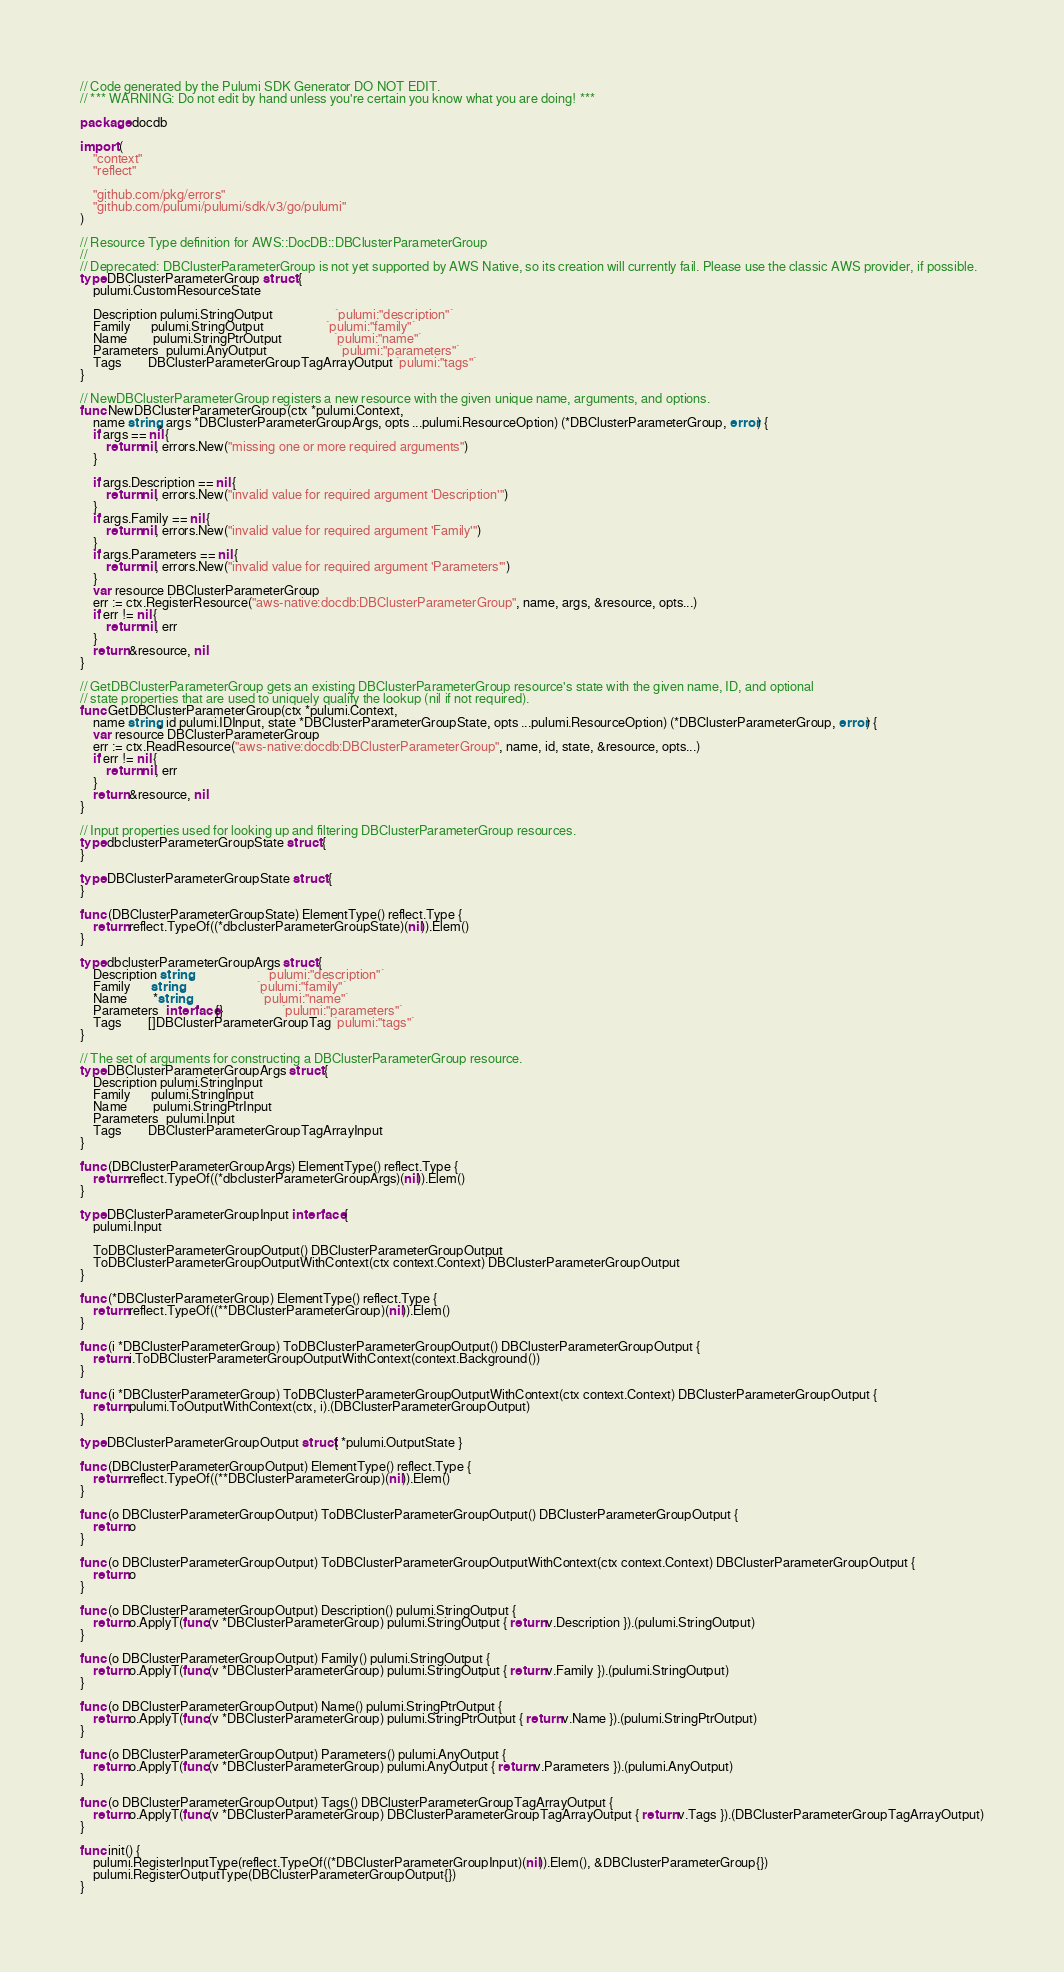<code> <loc_0><loc_0><loc_500><loc_500><_Go_>// Code generated by the Pulumi SDK Generator DO NOT EDIT.
// *** WARNING: Do not edit by hand unless you're certain you know what you are doing! ***

package docdb

import (
	"context"
	"reflect"

	"github.com/pkg/errors"
	"github.com/pulumi/pulumi/sdk/v3/go/pulumi"
)

// Resource Type definition for AWS::DocDB::DBClusterParameterGroup
//
// Deprecated: DBClusterParameterGroup is not yet supported by AWS Native, so its creation will currently fail. Please use the classic AWS provider, if possible.
type DBClusterParameterGroup struct {
	pulumi.CustomResourceState

	Description pulumi.StringOutput                   `pulumi:"description"`
	Family      pulumi.StringOutput                   `pulumi:"family"`
	Name        pulumi.StringPtrOutput                `pulumi:"name"`
	Parameters  pulumi.AnyOutput                      `pulumi:"parameters"`
	Tags        DBClusterParameterGroupTagArrayOutput `pulumi:"tags"`
}

// NewDBClusterParameterGroup registers a new resource with the given unique name, arguments, and options.
func NewDBClusterParameterGroup(ctx *pulumi.Context,
	name string, args *DBClusterParameterGroupArgs, opts ...pulumi.ResourceOption) (*DBClusterParameterGroup, error) {
	if args == nil {
		return nil, errors.New("missing one or more required arguments")
	}

	if args.Description == nil {
		return nil, errors.New("invalid value for required argument 'Description'")
	}
	if args.Family == nil {
		return nil, errors.New("invalid value for required argument 'Family'")
	}
	if args.Parameters == nil {
		return nil, errors.New("invalid value for required argument 'Parameters'")
	}
	var resource DBClusterParameterGroup
	err := ctx.RegisterResource("aws-native:docdb:DBClusterParameterGroup", name, args, &resource, opts...)
	if err != nil {
		return nil, err
	}
	return &resource, nil
}

// GetDBClusterParameterGroup gets an existing DBClusterParameterGroup resource's state with the given name, ID, and optional
// state properties that are used to uniquely qualify the lookup (nil if not required).
func GetDBClusterParameterGroup(ctx *pulumi.Context,
	name string, id pulumi.IDInput, state *DBClusterParameterGroupState, opts ...pulumi.ResourceOption) (*DBClusterParameterGroup, error) {
	var resource DBClusterParameterGroup
	err := ctx.ReadResource("aws-native:docdb:DBClusterParameterGroup", name, id, state, &resource, opts...)
	if err != nil {
		return nil, err
	}
	return &resource, nil
}

// Input properties used for looking up and filtering DBClusterParameterGroup resources.
type dbclusterParameterGroupState struct {
}

type DBClusterParameterGroupState struct {
}

func (DBClusterParameterGroupState) ElementType() reflect.Type {
	return reflect.TypeOf((*dbclusterParameterGroupState)(nil)).Elem()
}

type dbclusterParameterGroupArgs struct {
	Description string                       `pulumi:"description"`
	Family      string                       `pulumi:"family"`
	Name        *string                      `pulumi:"name"`
	Parameters  interface{}                  `pulumi:"parameters"`
	Tags        []DBClusterParameterGroupTag `pulumi:"tags"`
}

// The set of arguments for constructing a DBClusterParameterGroup resource.
type DBClusterParameterGroupArgs struct {
	Description pulumi.StringInput
	Family      pulumi.StringInput
	Name        pulumi.StringPtrInput
	Parameters  pulumi.Input
	Tags        DBClusterParameterGroupTagArrayInput
}

func (DBClusterParameterGroupArgs) ElementType() reflect.Type {
	return reflect.TypeOf((*dbclusterParameterGroupArgs)(nil)).Elem()
}

type DBClusterParameterGroupInput interface {
	pulumi.Input

	ToDBClusterParameterGroupOutput() DBClusterParameterGroupOutput
	ToDBClusterParameterGroupOutputWithContext(ctx context.Context) DBClusterParameterGroupOutput
}

func (*DBClusterParameterGroup) ElementType() reflect.Type {
	return reflect.TypeOf((**DBClusterParameterGroup)(nil)).Elem()
}

func (i *DBClusterParameterGroup) ToDBClusterParameterGroupOutput() DBClusterParameterGroupOutput {
	return i.ToDBClusterParameterGroupOutputWithContext(context.Background())
}

func (i *DBClusterParameterGroup) ToDBClusterParameterGroupOutputWithContext(ctx context.Context) DBClusterParameterGroupOutput {
	return pulumi.ToOutputWithContext(ctx, i).(DBClusterParameterGroupOutput)
}

type DBClusterParameterGroupOutput struct{ *pulumi.OutputState }

func (DBClusterParameterGroupOutput) ElementType() reflect.Type {
	return reflect.TypeOf((**DBClusterParameterGroup)(nil)).Elem()
}

func (o DBClusterParameterGroupOutput) ToDBClusterParameterGroupOutput() DBClusterParameterGroupOutput {
	return o
}

func (o DBClusterParameterGroupOutput) ToDBClusterParameterGroupOutputWithContext(ctx context.Context) DBClusterParameterGroupOutput {
	return o
}

func (o DBClusterParameterGroupOutput) Description() pulumi.StringOutput {
	return o.ApplyT(func(v *DBClusterParameterGroup) pulumi.StringOutput { return v.Description }).(pulumi.StringOutput)
}

func (o DBClusterParameterGroupOutput) Family() pulumi.StringOutput {
	return o.ApplyT(func(v *DBClusterParameterGroup) pulumi.StringOutput { return v.Family }).(pulumi.StringOutput)
}

func (o DBClusterParameterGroupOutput) Name() pulumi.StringPtrOutput {
	return o.ApplyT(func(v *DBClusterParameterGroup) pulumi.StringPtrOutput { return v.Name }).(pulumi.StringPtrOutput)
}

func (o DBClusterParameterGroupOutput) Parameters() pulumi.AnyOutput {
	return o.ApplyT(func(v *DBClusterParameterGroup) pulumi.AnyOutput { return v.Parameters }).(pulumi.AnyOutput)
}

func (o DBClusterParameterGroupOutput) Tags() DBClusterParameterGroupTagArrayOutput {
	return o.ApplyT(func(v *DBClusterParameterGroup) DBClusterParameterGroupTagArrayOutput { return v.Tags }).(DBClusterParameterGroupTagArrayOutput)
}

func init() {
	pulumi.RegisterInputType(reflect.TypeOf((*DBClusterParameterGroupInput)(nil)).Elem(), &DBClusterParameterGroup{})
	pulumi.RegisterOutputType(DBClusterParameterGroupOutput{})
}
</code> 